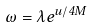Convert formula to latex. <formula><loc_0><loc_0><loc_500><loc_500>\omega = \lambda e ^ { u / 4 M }</formula> 